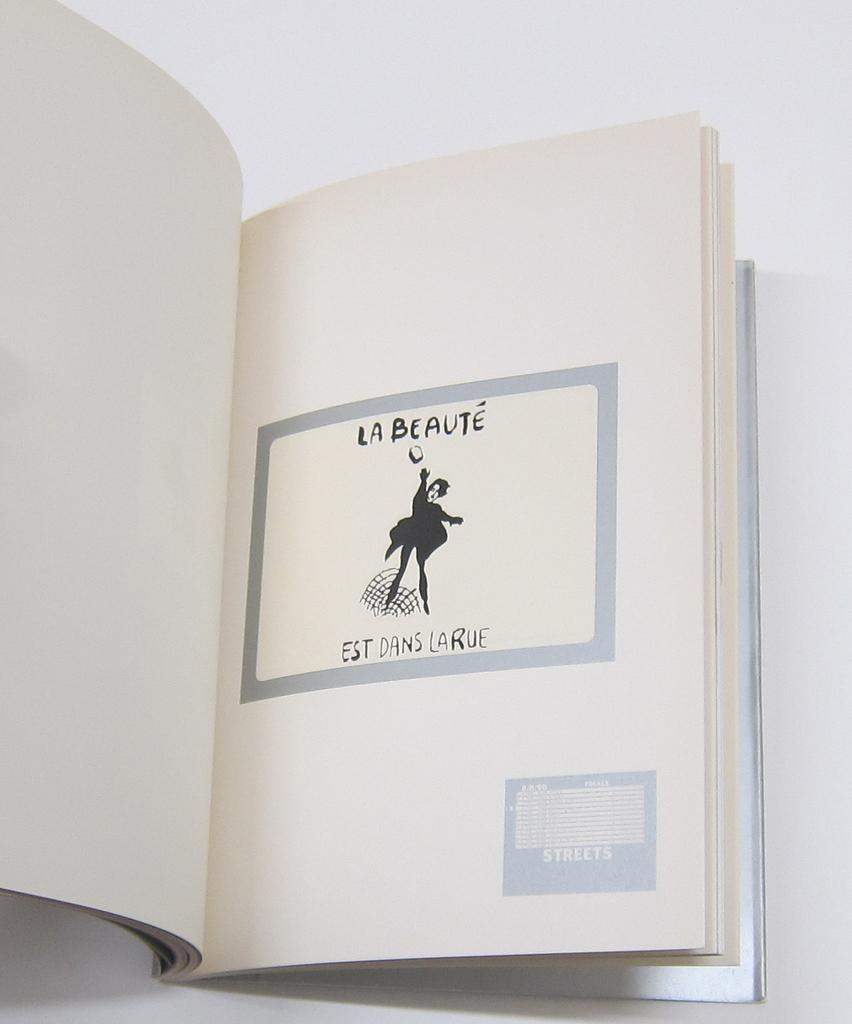<image>
Write a terse but informative summary of the picture. La Beaute is written over a black and white drawing of a person. 